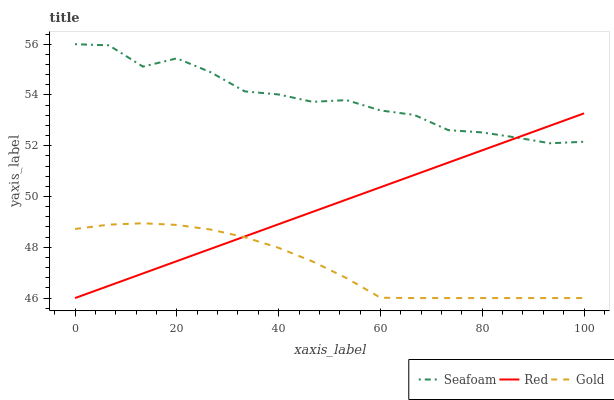Does Gold have the minimum area under the curve?
Answer yes or no. Yes. Does Seafoam have the maximum area under the curve?
Answer yes or no. Yes. Does Red have the minimum area under the curve?
Answer yes or no. No. Does Red have the maximum area under the curve?
Answer yes or no. No. Is Red the smoothest?
Answer yes or no. Yes. Is Seafoam the roughest?
Answer yes or no. Yes. Is Seafoam the smoothest?
Answer yes or no. No. Is Red the roughest?
Answer yes or no. No. Does Gold have the lowest value?
Answer yes or no. Yes. Does Seafoam have the lowest value?
Answer yes or no. No. Does Seafoam have the highest value?
Answer yes or no. Yes. Does Red have the highest value?
Answer yes or no. No. Is Gold less than Seafoam?
Answer yes or no. Yes. Is Seafoam greater than Gold?
Answer yes or no. Yes. Does Red intersect Seafoam?
Answer yes or no. Yes. Is Red less than Seafoam?
Answer yes or no. No. Is Red greater than Seafoam?
Answer yes or no. No. Does Gold intersect Seafoam?
Answer yes or no. No. 